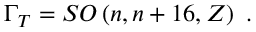Convert formula to latex. <formula><loc_0><loc_0><loc_500><loc_500>\Gamma _ { T } = S O \left ( n , n + 1 6 , Z \right ) \ .</formula> 